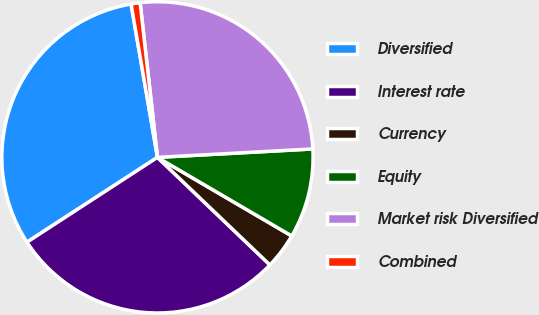Convert chart. <chart><loc_0><loc_0><loc_500><loc_500><pie_chart><fcel>Diversified<fcel>Interest rate<fcel>Currency<fcel>Equity<fcel>Market risk Diversified<fcel>Combined<nl><fcel>31.46%<fcel>28.68%<fcel>3.72%<fcel>9.29%<fcel>25.91%<fcel>0.94%<nl></chart> 